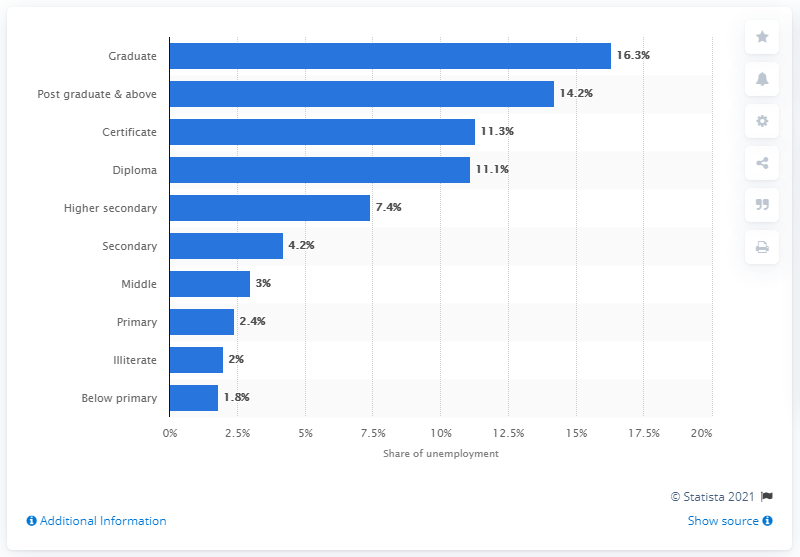What percentage of graduates made up the highest unemployment rate in 2019?
 16.3 